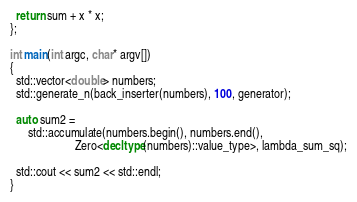<code> <loc_0><loc_0><loc_500><loc_500><_C++_>  return sum + x * x;
};

int main(int argc, char* argv[])
{
  std::vector<double> numbers;
  std::generate_n(back_inserter(numbers), 100, generator);

  auto sum2 =
      std::accumulate(numbers.begin(), numbers.end(),
                      Zero<decltype(numbers)::value_type>, lambda_sum_sq);

  std::cout << sum2 << std::endl;
}
</code> 